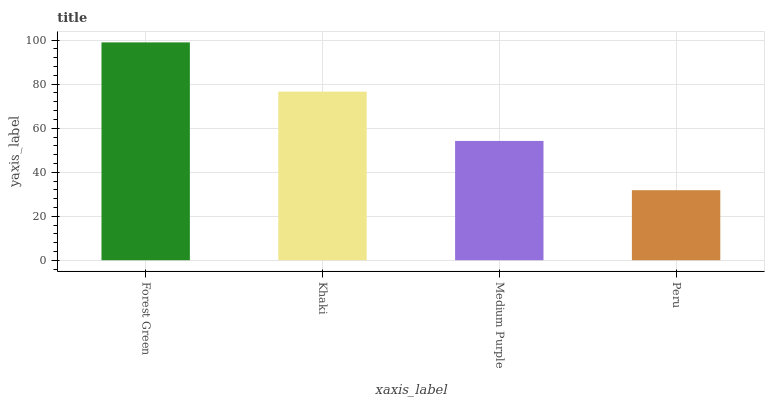Is Peru the minimum?
Answer yes or no. Yes. Is Forest Green the maximum?
Answer yes or no. Yes. Is Khaki the minimum?
Answer yes or no. No. Is Khaki the maximum?
Answer yes or no. No. Is Forest Green greater than Khaki?
Answer yes or no. Yes. Is Khaki less than Forest Green?
Answer yes or no. Yes. Is Khaki greater than Forest Green?
Answer yes or no. No. Is Forest Green less than Khaki?
Answer yes or no. No. Is Khaki the high median?
Answer yes or no. Yes. Is Medium Purple the low median?
Answer yes or no. Yes. Is Medium Purple the high median?
Answer yes or no. No. Is Peru the low median?
Answer yes or no. No. 